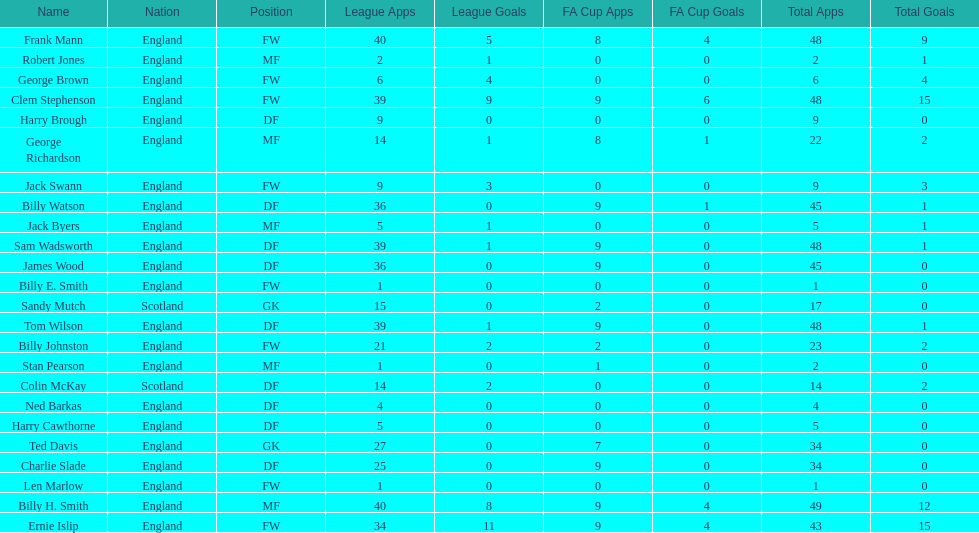What is the first name listed? Ned Barkas. 